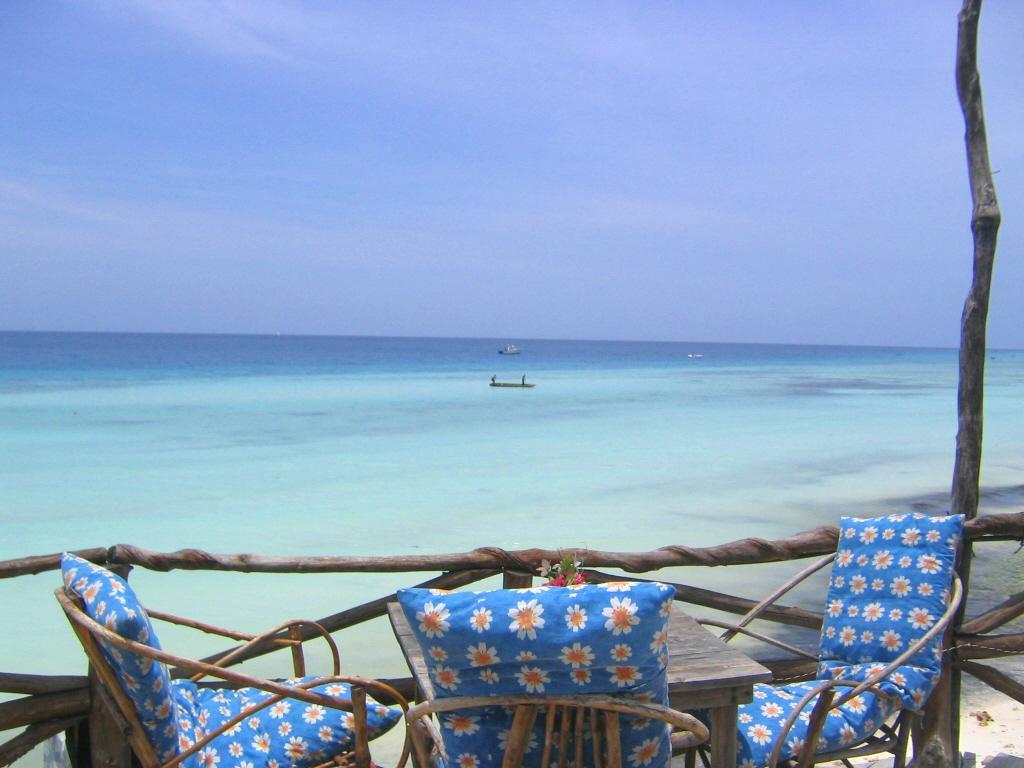Could you give a brief overview of what you see in this image? In the picture we can see a sea with blue color water and near to it, we can see a sand surface with a railing of sticks and behind it, we can see some chairs and table, on the chairs we can see some pillows and on the table, we can see some plants and flowers to it and in the sea we can see some boats and some persons standing on it and behind it we can see a sky which is blue in color. 